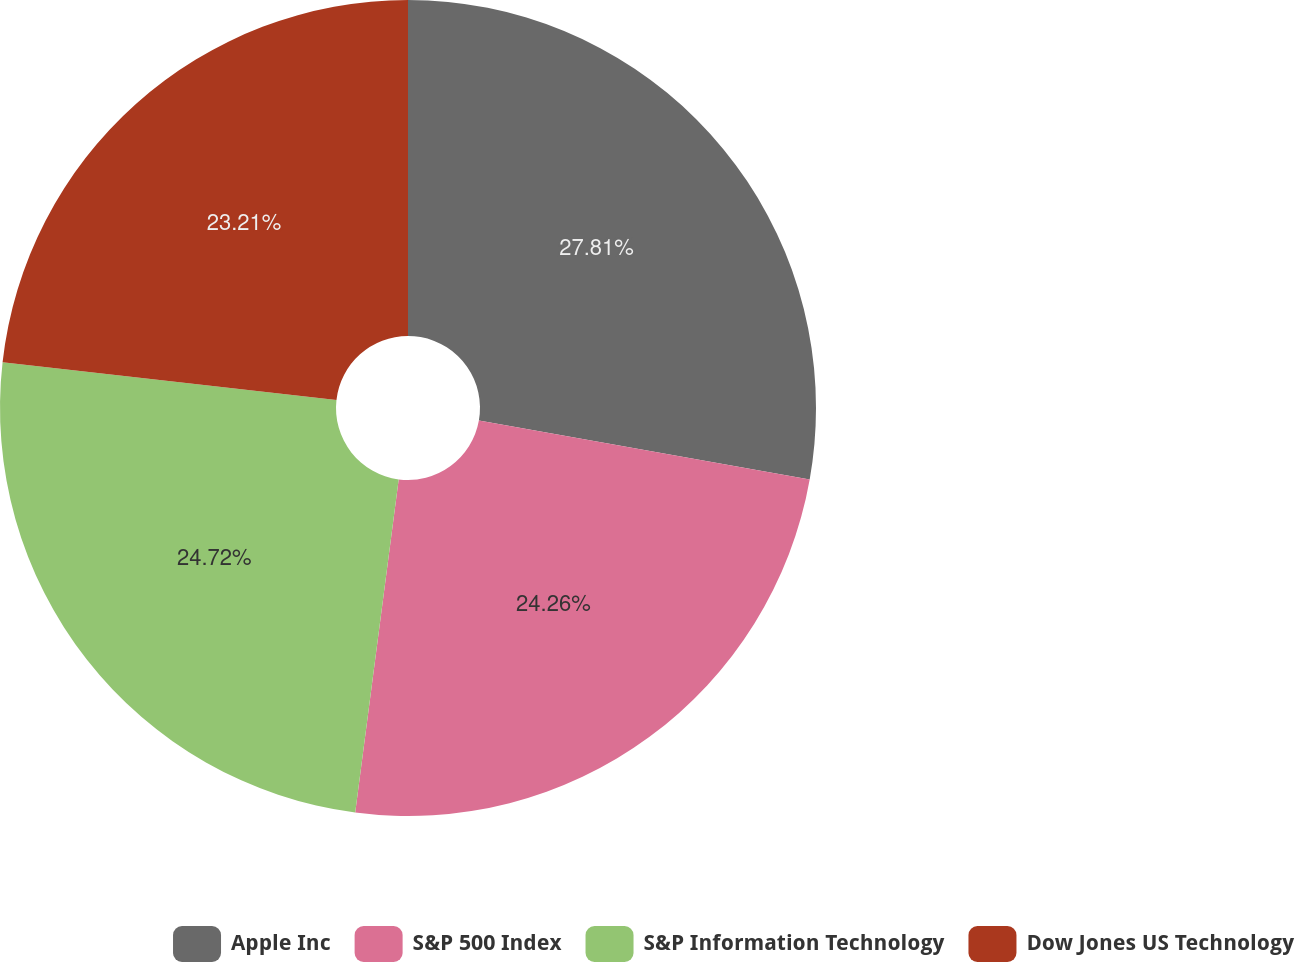<chart> <loc_0><loc_0><loc_500><loc_500><pie_chart><fcel>Apple Inc<fcel>S&P 500 Index<fcel>S&P Information Technology<fcel>Dow Jones US Technology<nl><fcel>27.8%<fcel>24.26%<fcel>24.72%<fcel>23.21%<nl></chart> 